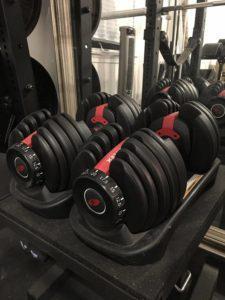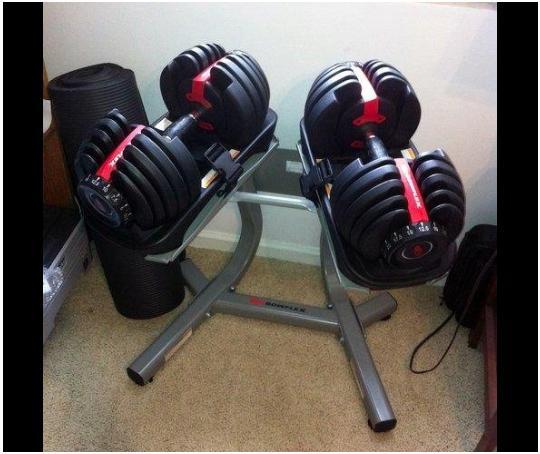The first image is the image on the left, the second image is the image on the right. Given the left and right images, does the statement "In at least one image there is a single hand adjusting a red and black weight." hold true? Answer yes or no. No. 